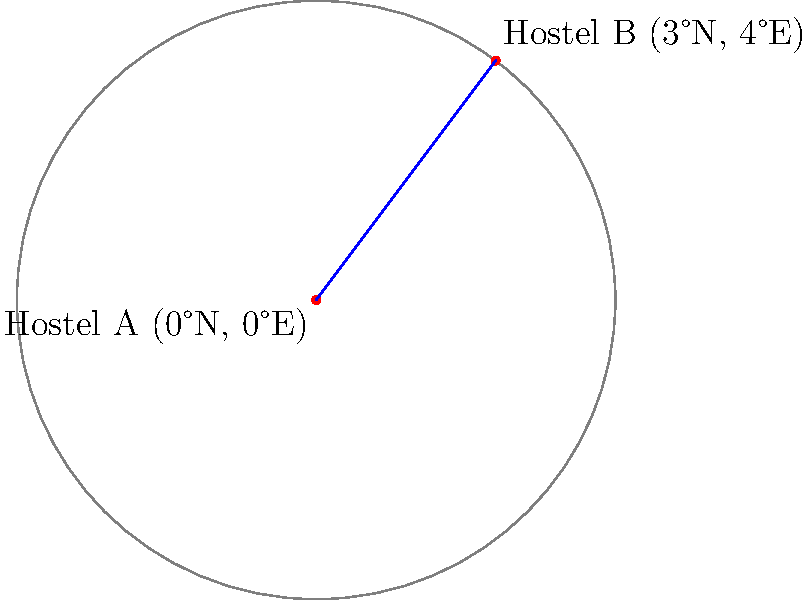You're planning to open a new hostel and want to analyze the competition in the area. You've found two popular hostels, Hostel A located at 0°N, 0°E and Hostel B at 3°N, 4°E. Assuming the Earth is a perfect sphere with a radius of 6,371 km, what is the approximate distance between these two hostels along the Earth's surface? To calculate the distance between two points on a sphere (in this case, the Earth), we can use the Haversine formula:

1. Convert latitude and longitude to radians:
   $$\text{lat1} = 0° \times \frac{\pi}{180} = 0 \text{ rad}$$
   $$\text{lon1} = 0° \times \frac{\pi}{180} = 0 \text{ rad}$$
   $$\text{lat2} = 3° \times \frac{\pi}{180} \approx 0.0524 \text{ rad}$$
   $$\text{lon2} = 4° \times \frac{\pi}{180} \approx 0.0698 \text{ rad}$$

2. Calculate the differences:
   $$\Delta\text{lat} = \text{lat2} - \text{lat1} \approx 0.0524 \text{ rad}$$
   $$\Delta\text{lon} = \text{lon2} - \text{lon1} \approx 0.0698 \text{ rad}$$

3. Apply the Haversine formula:
   $$a = \sin^2(\frac{\Delta\text{lat}}{2}) + \cos(\text{lat1}) \times \cos(\text{lat2}) \times \sin^2(\frac{\Delta\text{lon}}{2})$$
   $$a \approx \sin^2(0.0262) + \cos(0) \times \cos(0.0524) \times \sin^2(0.0349) \approx 0.0025$$

4. Calculate the central angle:
   $$c = 2 \times \arctan2(\sqrt{a}, \sqrt{1-a}) \approx 0.1003 \text{ rad}$$

5. Calculate the distance:
   $$d = R \times c$$
   where $R$ is the Earth's radius (6,371 km)
   $$d \approx 6371 \times 0.1003 \approx 639 \text{ km}$$

Therefore, the approximate distance between Hostel A and Hostel B is 639 km.
Answer: 639 km 